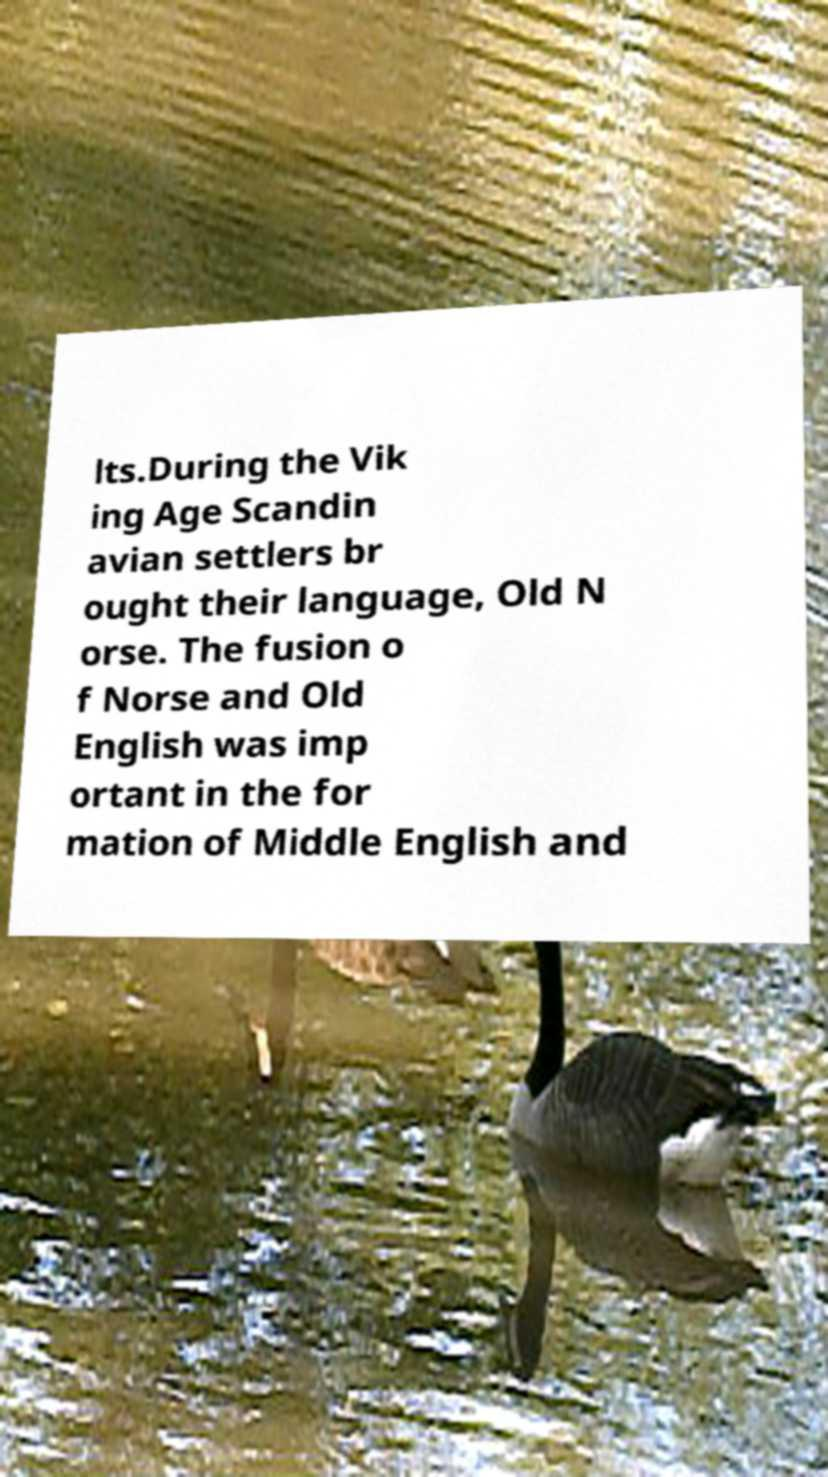Please read and relay the text visible in this image. What does it say? lts.During the Vik ing Age Scandin avian settlers br ought their language, Old N orse. The fusion o f Norse and Old English was imp ortant in the for mation of Middle English and 